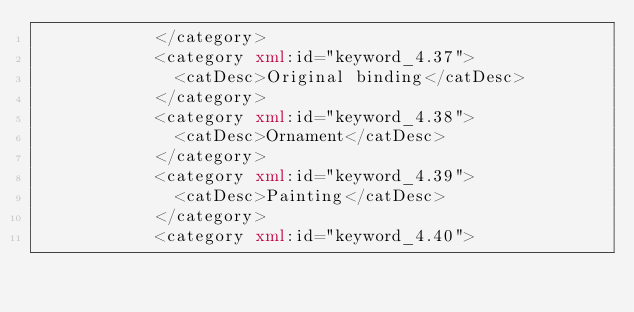Convert code to text. <code><loc_0><loc_0><loc_500><loc_500><_XML_>            </category>
            <category xml:id="keyword_4.37">
              <catDesc>Original binding</catDesc>
            </category>
            <category xml:id="keyword_4.38">
              <catDesc>Ornament</catDesc>
            </category>
            <category xml:id="keyword_4.39">
              <catDesc>Painting</catDesc>
            </category>
            <category xml:id="keyword_4.40"></code> 